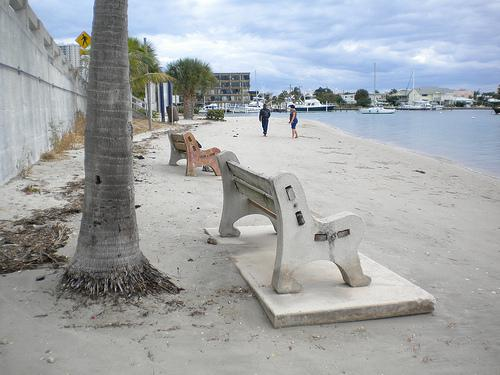Question: why is there a bench?
Choices:
A. For people to sit on.
B. Park.
C. Sitting.
D. Laying on.
Answer with the letter. Answer: A Question: how many benches are there?
Choices:
A. Two.
B. Three.
C. Four.
D. Five.
Answer with the letter. Answer: A Question: what are the people doing?
Choices:
A. Eating.
B. Sleeping.
C. Walking.
D. Shopping.
Answer with the letter. Answer: C Question: when was the photo taken?
Choices:
A. At night.
B. At dawn.
C. At dusk.
D. During the day.
Answer with the letter. Answer: D Question: what is next to the beach?
Choices:
A. The river.
B. The lake.
C. A mud pit.
D. The ocean.
Answer with the letter. Answer: D 